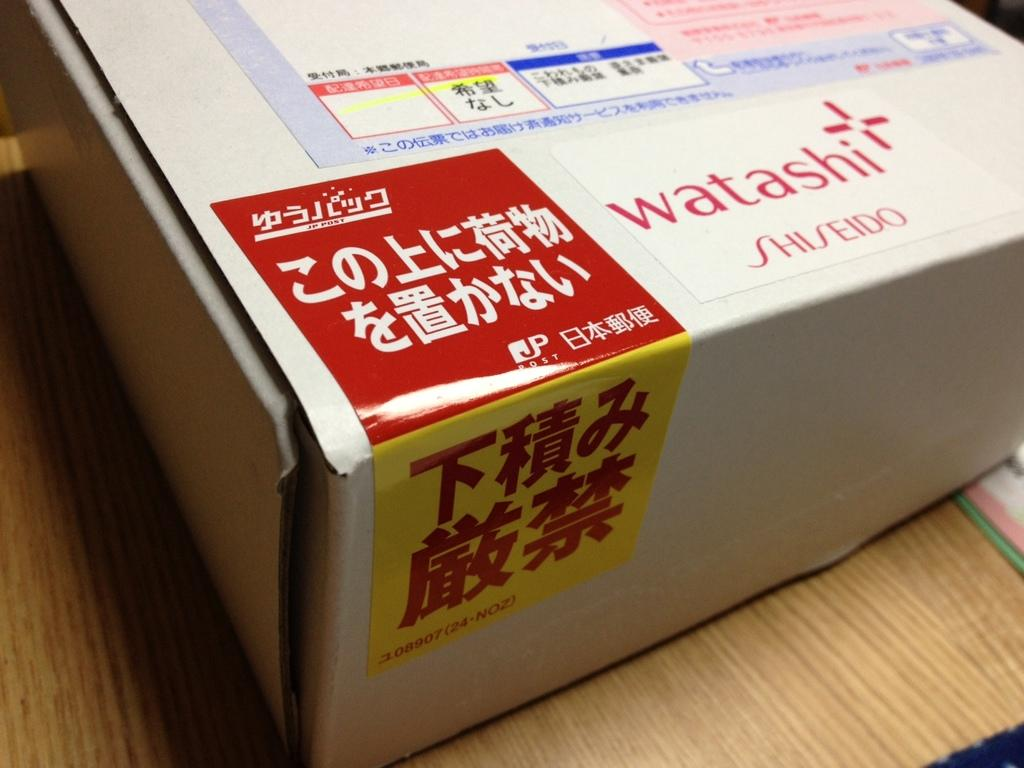What object is present in the image that is made of cardboard? There is a cardboard box in the image. What is the cardboard box placed on? The cardboard box is on a cream-colored surface. How is the pail being used during the rainstorm in the image? There is no pail or rainstorm present in the image; it only features a cardboard box on a cream-colored surface. colored surface. 